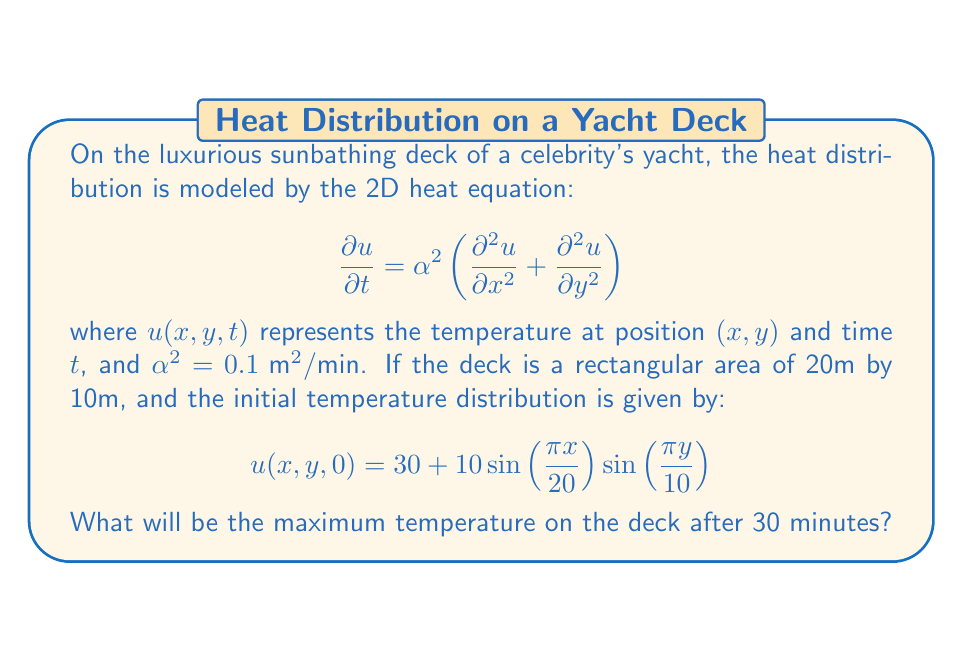Teach me how to tackle this problem. To solve this problem, we'll follow these steps:

1) The general solution to the 2D heat equation with the given initial condition is:

   $$u(x,y,t) = 30 + 10 \sin\left(\frac{\pi x}{20}\right) \sin\left(\frac{\pi y}{10}\right) e^{-\alpha^2 \pi^2 t \left(\frac{1}{400} + \frac{1}{100}\right)}$$

2) We need to find the maximum value of this function at t = 30 minutes.

3) The exponential term will always be positive and less than 1, so the maximum will occur when the sine terms are at their maximum (which is 1).

4) Let's calculate the value of the exponential term:

   $$e^{-0.1 \pi^2 \cdot 30 \left(\frac{1}{400} + \frac{1}{100}\right)} = e^{-0.1 \pi^2 \cdot 30 \cdot 0.0125} \approx 0.3305$$

5) Now, we can calculate the maximum temperature:

   $$u_{max} = 30 + 10 \cdot 1 \cdot 1 \cdot 0.3305 = 33.305°C$$

Therefore, the maximum temperature on the deck after 30 minutes will be approximately 33.305°C.
Answer: 33.305°C 